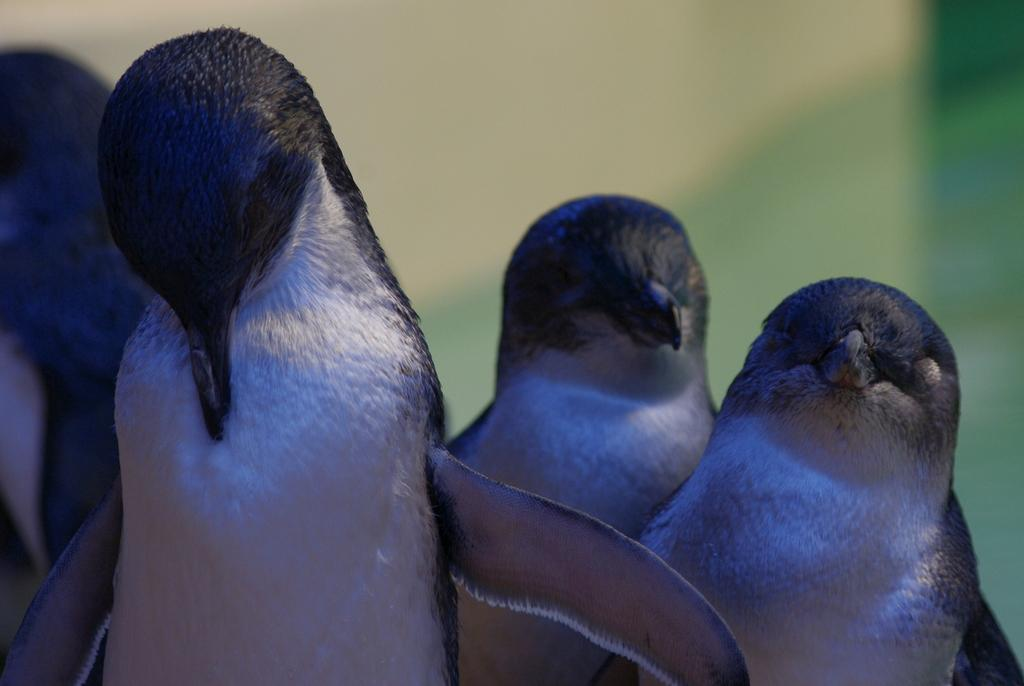Where was the image taken? The image was taken outdoors. Can you describe the background of the image? The background of the image is slightly blurred. What is the main subject of the image? There are four penguins in the middle of the image. What type of garden can be seen in the background of the image? There is no garden present in the image; it features four penguins in the outdoors. Where is the store located in the image? There is no store present in the image; it features four penguins in the outdoors. 